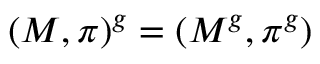Convert formula to latex. <formula><loc_0><loc_0><loc_500><loc_500>( M , \pi ) ^ { g } = ( M ^ { g } , \pi ^ { g } )</formula> 